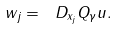Convert formula to latex. <formula><loc_0><loc_0><loc_500><loc_500>w _ { j } = \ D _ { x _ { j } } Q _ { \gamma } u .</formula> 